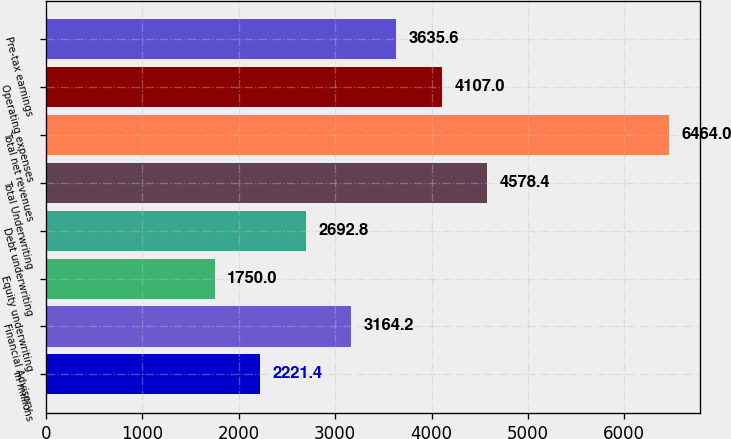Convert chart. <chart><loc_0><loc_0><loc_500><loc_500><bar_chart><fcel>in millions<fcel>Financial Advisory<fcel>Equity underwriting<fcel>Debt underwriting<fcel>Total Underwriting<fcel>Total net revenues<fcel>Operating expenses<fcel>Pre-tax earnings<nl><fcel>2221.4<fcel>3164.2<fcel>1750<fcel>2692.8<fcel>4578.4<fcel>6464<fcel>4107<fcel>3635.6<nl></chart> 